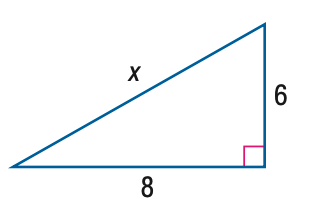Answer the mathemtical geometry problem and directly provide the correct option letter.
Question: Find x.
Choices: A: 5.3 B: 6 C: 8 D: 10 D 